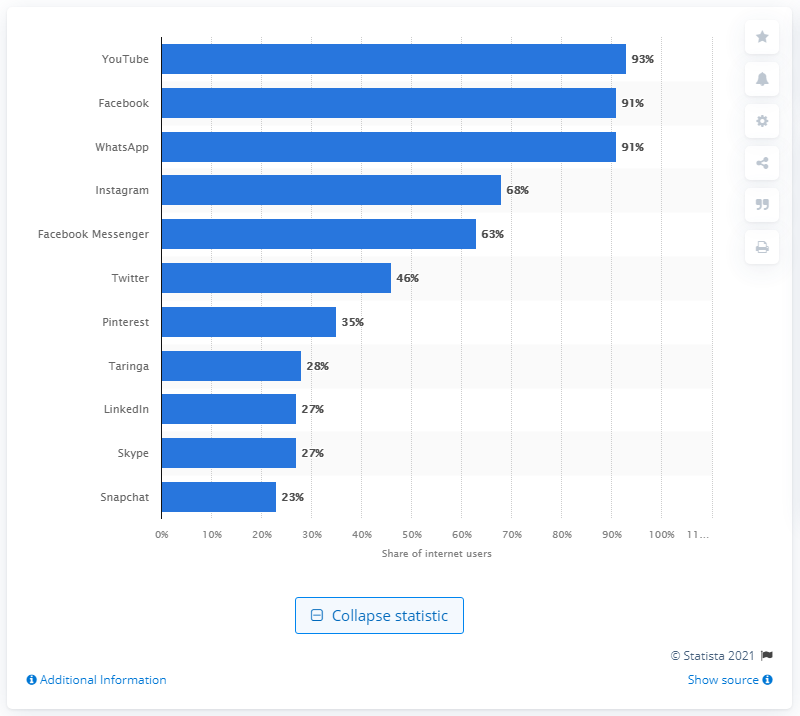Give some essential details in this illustration. In the survey conducted in Argentina, 91% of the respondents mentioned both Facebook and WhatsApp. According to data from the third quarter of 2018, YouTube was the most popular social media platform in Argentina. 